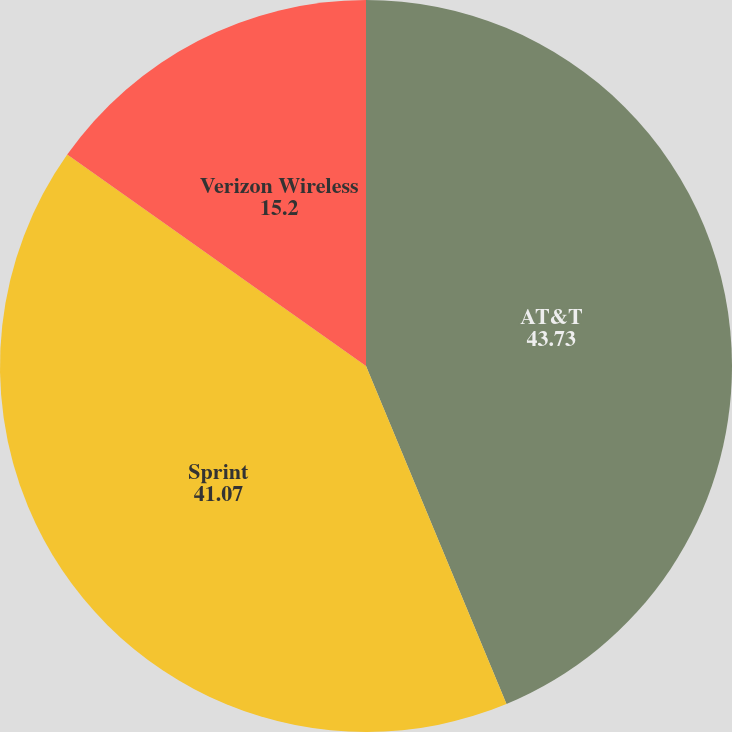Convert chart to OTSL. <chart><loc_0><loc_0><loc_500><loc_500><pie_chart><fcel>AT&T<fcel>Sprint<fcel>Verizon Wireless<nl><fcel>43.73%<fcel>41.07%<fcel>15.2%<nl></chart> 